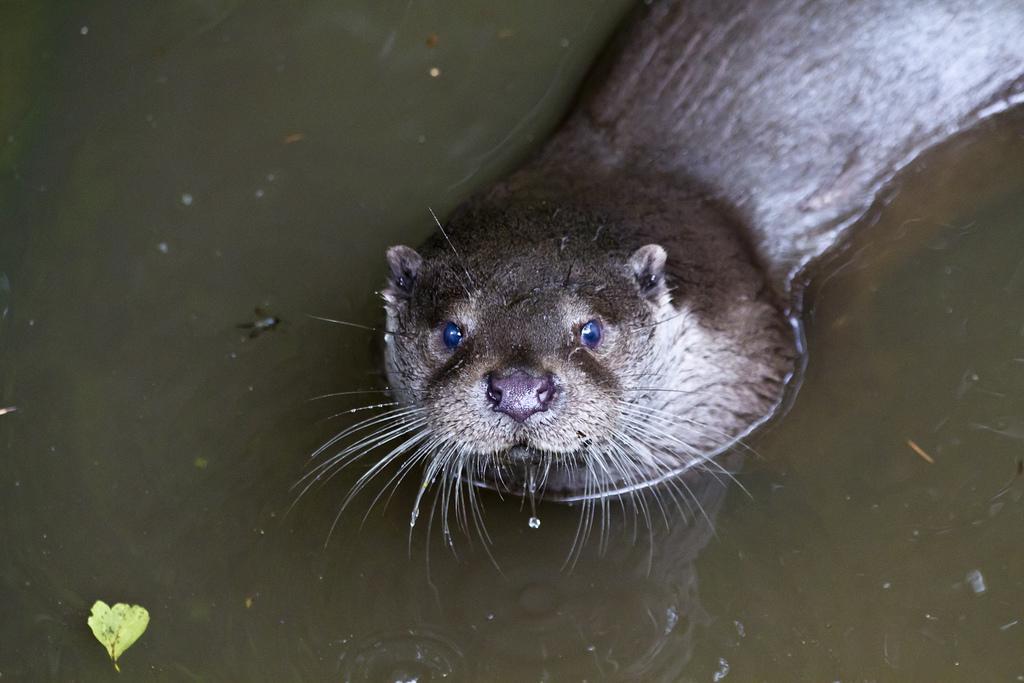Could you give a brief overview of what you see in this image? In this picture, we see the seal. In the background, we see water and this water might be in the pond. At the bottom, we see a leaf. 